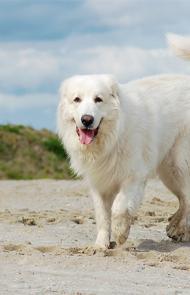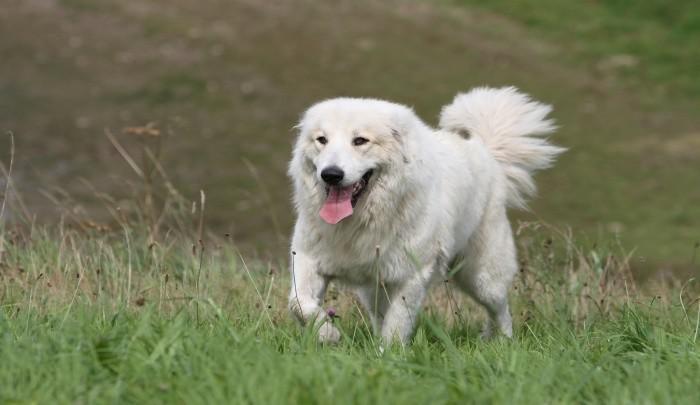The first image is the image on the left, the second image is the image on the right. For the images displayed, is the sentence "If one dog is lying down, there are no sitting dogs near them." factually correct? Answer yes or no. No. The first image is the image on the left, the second image is the image on the right. Analyze the images presented: Is the assertion "There is a single, white dog lying down in the right image." valid? Answer yes or no. No. 